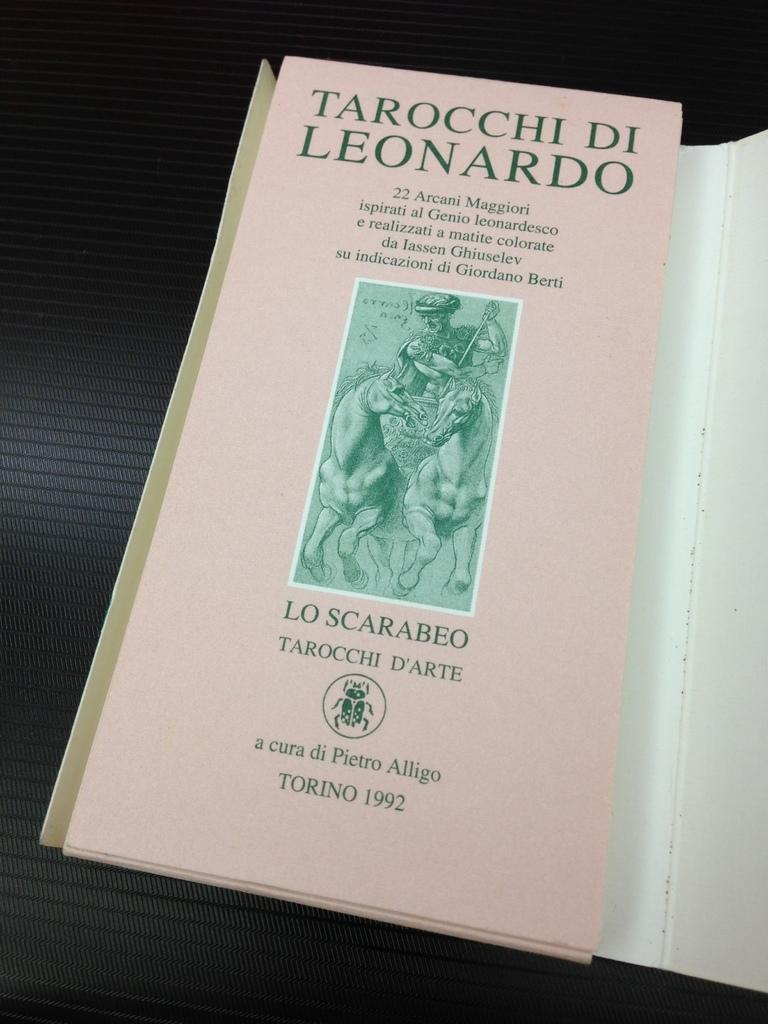<image>
Render a clear and concise summary of the photo. A book called Tarocchi di Leonardo has a pale pink cover. 